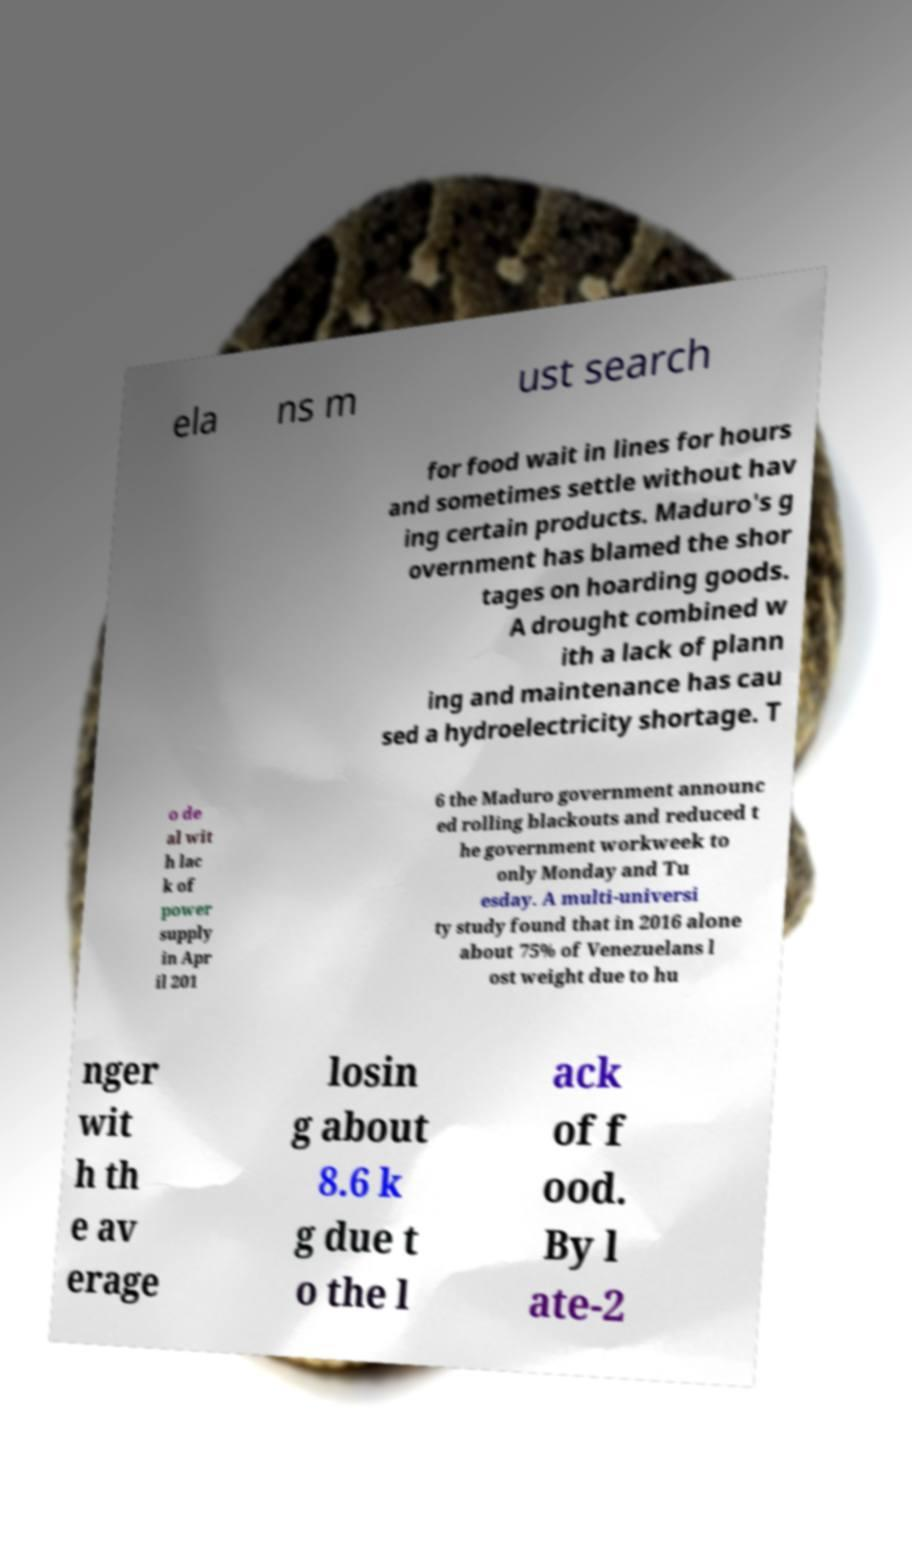I need the written content from this picture converted into text. Can you do that? ela ns m ust search for food wait in lines for hours and sometimes settle without hav ing certain products. Maduro's g overnment has blamed the shor tages on hoarding goods. A drought combined w ith a lack of plann ing and maintenance has cau sed a hydroelectricity shortage. T o de al wit h lac k of power supply in Apr il 201 6 the Maduro government announc ed rolling blackouts and reduced t he government workweek to only Monday and Tu esday. A multi-universi ty study found that in 2016 alone about 75% of Venezuelans l ost weight due to hu nger wit h th e av erage losin g about 8.6 k g due t o the l ack of f ood. By l ate-2 